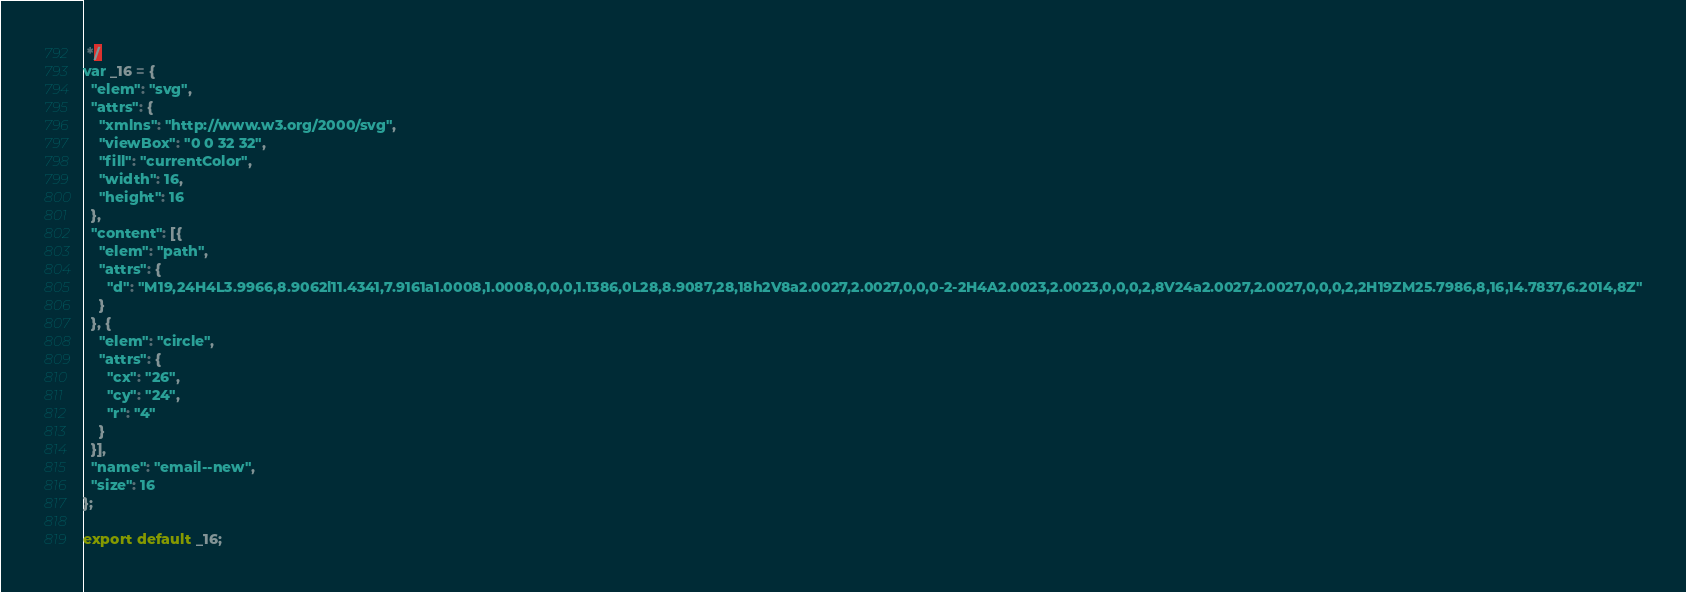<code> <loc_0><loc_0><loc_500><loc_500><_JavaScript_> */
var _16 = {
  "elem": "svg",
  "attrs": {
    "xmlns": "http://www.w3.org/2000/svg",
    "viewBox": "0 0 32 32",
    "fill": "currentColor",
    "width": 16,
    "height": 16
  },
  "content": [{
    "elem": "path",
    "attrs": {
      "d": "M19,24H4L3.9966,8.9062l11.4341,7.9161a1.0008,1.0008,0,0,0,1.1386,0L28,8.9087,28,18h2V8a2.0027,2.0027,0,0,0-2-2H4A2.0023,2.0023,0,0,0,2,8V24a2.0027,2.0027,0,0,0,2,2H19ZM25.7986,8,16,14.7837,6.2014,8Z"
    }
  }, {
    "elem": "circle",
    "attrs": {
      "cx": "26",
      "cy": "24",
      "r": "4"
    }
  }],
  "name": "email--new",
  "size": 16
};

export default _16;
</code> 